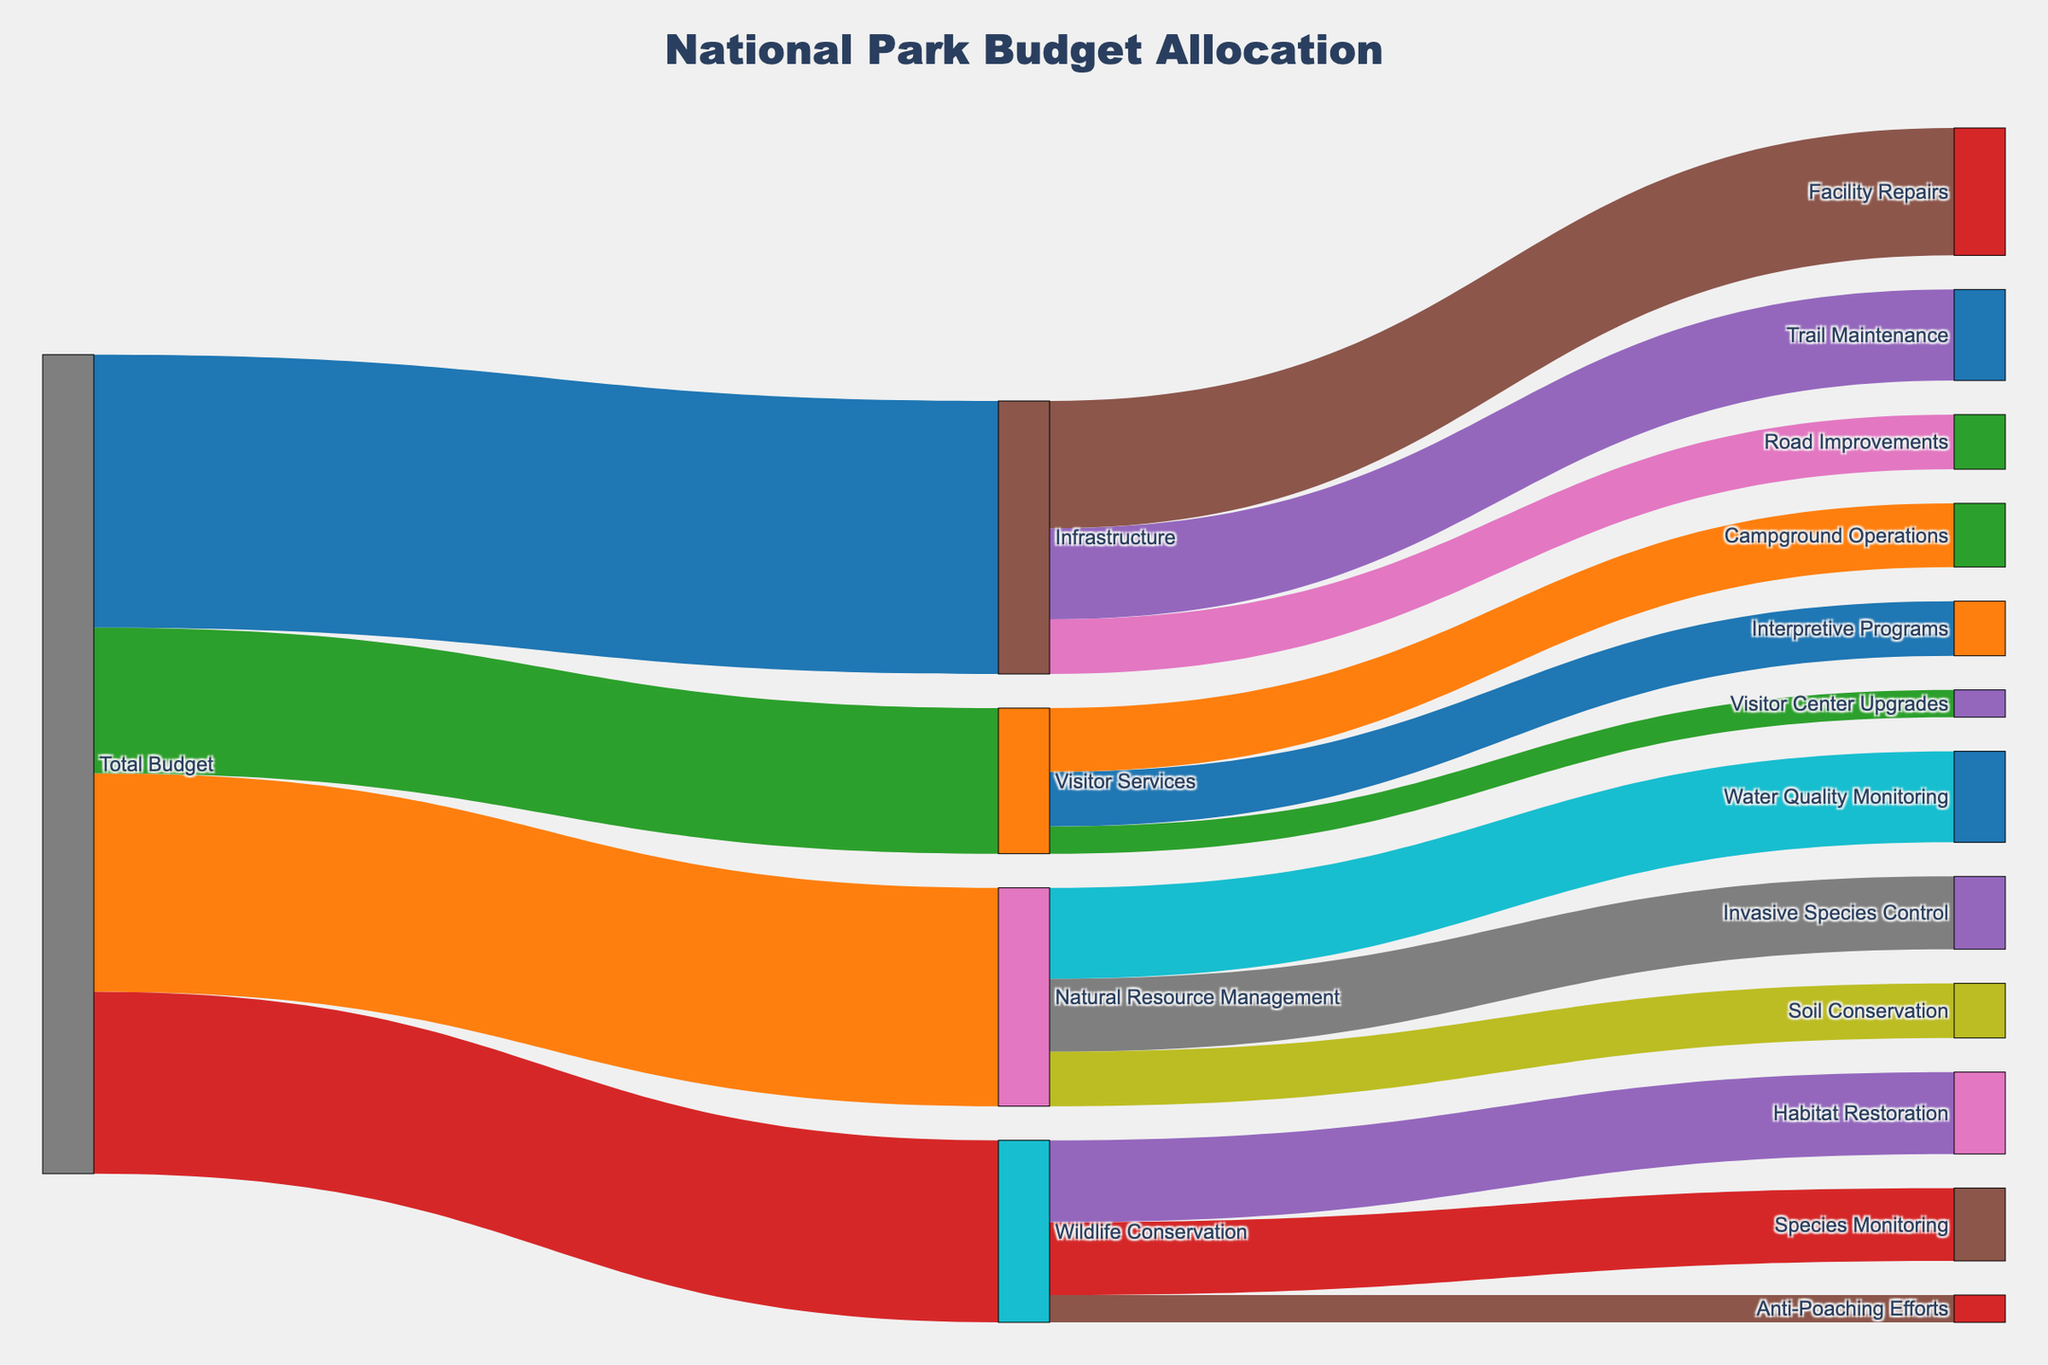What's the total budget allocated for Visitor Services? The figure shows the total budget flowing into different departments. By looking at the Visitor Services link, we can see it receives $8,000,000.
Answer: $8,000,000 How much budget is allocated for Trail Maintenance within the Infrastructure department? Trail Maintenance is a sub-category within Infrastructure. The link shows that $5,000,000 is allocated for Trail Maintenance.
Answer: $5,000,000 Which department has the second highest budget allocation? By looking at the flows from the Total Budget block, Natural Resource Management has the second highest allocation with $12,000,000, after Infrastructure.
Answer: Natural Resource Management What is the combined budget for Water Quality Monitoring and Invasive Species Control? These are both projects under Natural Resource Management. The budget for Water Quality Monitoring is $5,000,000 and for Invasive Species Control is $4,000,000. Summing them up, we get $5,000,000 + $4,000,000 = $9,000,000.
Answer: $9,000,000 How does the budget for Habitat Restoration compare to that for Campground Operations? Habitat Restoration, under Wildlife Conservation, has $4,500,000 allocated. Campground Operations, under Visitor Services, has $3,500,000 allocated. Comparing them, Habitat Restoration has $1,000,000 more budget than Campground Operations.
Answer: Habitat Restoration has $1,000,000 more What portion of the total budget is allocated to Facility Repairs? Facility Repairs falls under Infrastructure with an allocation of $7,000,000. The total budget is the sum of all category allocations: $15,000,000 (Infrastructure) + $12,000,000 (Natural Resource Management) + $8,000,000 (Visitor Services) + $10,000,000 (Wildlife Conservation) = $45,000,000. Therefore, the portion for Facility Repairs is $7,000,000 / $45,000,000.
Answer: Approximately 15.56% How does the budget for Anti-Poaching Efforts compare to Interpretive Programs? Anti-Poaching Efforts under Wildlife Conservation has an allocation of $1,500,000, while Interpretive Programs under Visitor Services has an allocation of $3,000,000. Comparing them, Interpretive Programs has $1,500,000 more budget.
Answer: Interpretive Programs has $1,500,000 more Which project has the smallest budget allocation? By looking at all the project allocations, Anti-Poaching Efforts has the smallest allocation with $1,500,000.
Answer: Anti-Poaching Efforts What is the total budget allocated to projects under Infrastructure? Projects under Infrastructure include Trail Maintenance ($5,000,000), Facility Repairs ($7,000,000), and Road Improvements ($3,000,000). Summing these, $5,000,000 + $7,000,000 + $3,000,000 = $15,000,000.
Answer: $15,000,000 Which has a higher budget: Soil Conservation or Visitor Center Upgrades? Soil Conservation, under Natural Resource Management, has a budget of $3,000,000. Visitor Center Upgrades, under Visitor Services, has a budget of $1,500,000. Soil Conservation's budget is higher.
Answer: Soil Conservation 